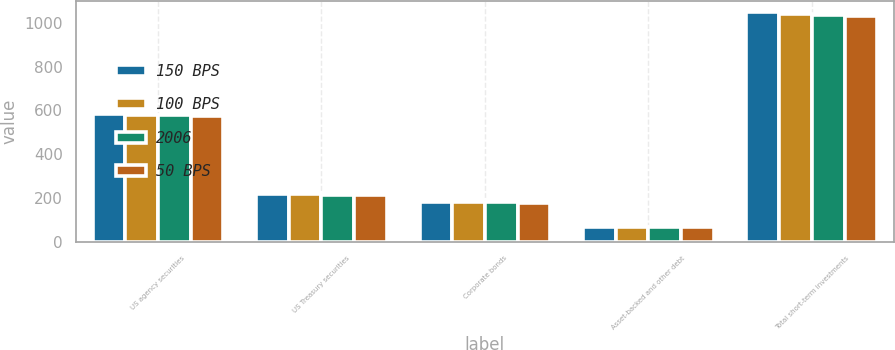Convert chart to OTSL. <chart><loc_0><loc_0><loc_500><loc_500><stacked_bar_chart><ecel><fcel>US agency securities<fcel>US Treasury securities<fcel>Corporate bonds<fcel>Asset-backed and other debt<fcel>Total short-term investments<nl><fcel>150 BPS<fcel>581<fcel>218<fcel>182<fcel>66<fcel>1047<nl><fcel>100 BPS<fcel>579<fcel>216<fcel>181<fcel>66<fcel>1042<nl><fcel>2006<fcel>577<fcel>214<fcel>179<fcel>66<fcel>1036<nl><fcel>50 BPS<fcel>575<fcel>212<fcel>178<fcel>65<fcel>1030<nl></chart> 